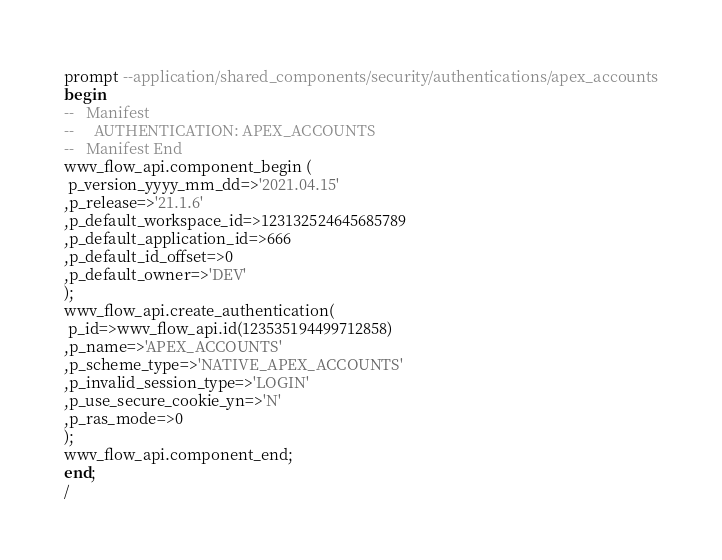Convert code to text. <code><loc_0><loc_0><loc_500><loc_500><_SQL_>prompt --application/shared_components/security/authentications/apex_accounts
begin
--   Manifest
--     AUTHENTICATION: APEX_ACCOUNTS
--   Manifest End
wwv_flow_api.component_begin (
 p_version_yyyy_mm_dd=>'2021.04.15'
,p_release=>'21.1.6'
,p_default_workspace_id=>123132524645685789
,p_default_application_id=>666
,p_default_id_offset=>0
,p_default_owner=>'DEV'
);
wwv_flow_api.create_authentication(
 p_id=>wwv_flow_api.id(123535194499712858)
,p_name=>'APEX_ACCOUNTS'
,p_scheme_type=>'NATIVE_APEX_ACCOUNTS'
,p_invalid_session_type=>'LOGIN'
,p_use_secure_cookie_yn=>'N'
,p_ras_mode=>0
);
wwv_flow_api.component_end;
end;
/
</code> 